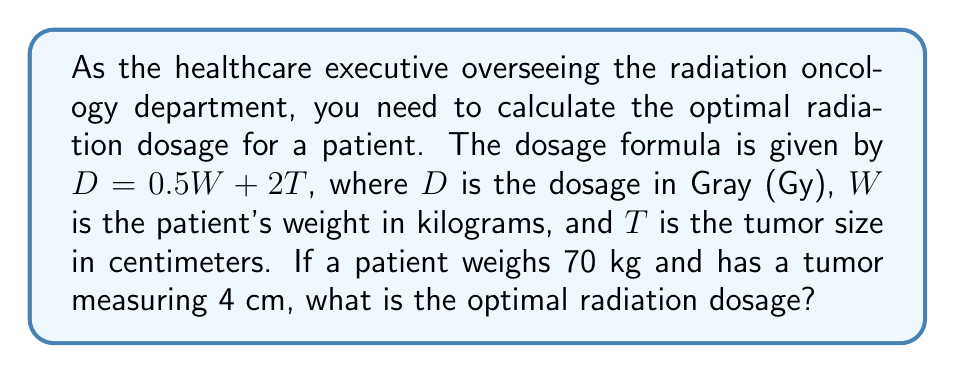Help me with this question. To solve this problem, we'll follow these steps:

1. Identify the given information:
   - Patient's weight ($W$) = 70 kg
   - Tumor size ($T$) = 4 cm
   - Dosage formula: $D = 0.5W + 2T$

2. Substitute the known values into the formula:
   $D = 0.5(70) + 2(4)$

3. Calculate the first term:
   $0.5(70) = 35$

4. Calculate the second term:
   $2(4) = 8$

5. Add the two terms:
   $D = 35 + 8 = 43$

Therefore, the optimal radiation dosage for this patient is 43 Gy.
Answer: 43 Gy 